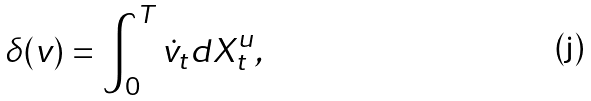Convert formula to latex. <formula><loc_0><loc_0><loc_500><loc_500>\delta ( v ) = \int _ { 0 } ^ { T } \dot { v } _ { t } d X ^ { u } _ { t } ,</formula> 